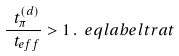<formula> <loc_0><loc_0><loc_500><loc_500>\frac { \ t _ { \pi } ^ { ( d ) } } { \ t _ { e f f } } > 1 \, . \ e q l a b e l { t r a t }</formula> 